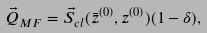Convert formula to latex. <formula><loc_0><loc_0><loc_500><loc_500>\vec { Q } _ { M F } = \vec { S } _ { c l } ( \bar { z } ^ { ( 0 ) } , z ^ { ( 0 ) } ) ( 1 - \delta ) ,</formula> 